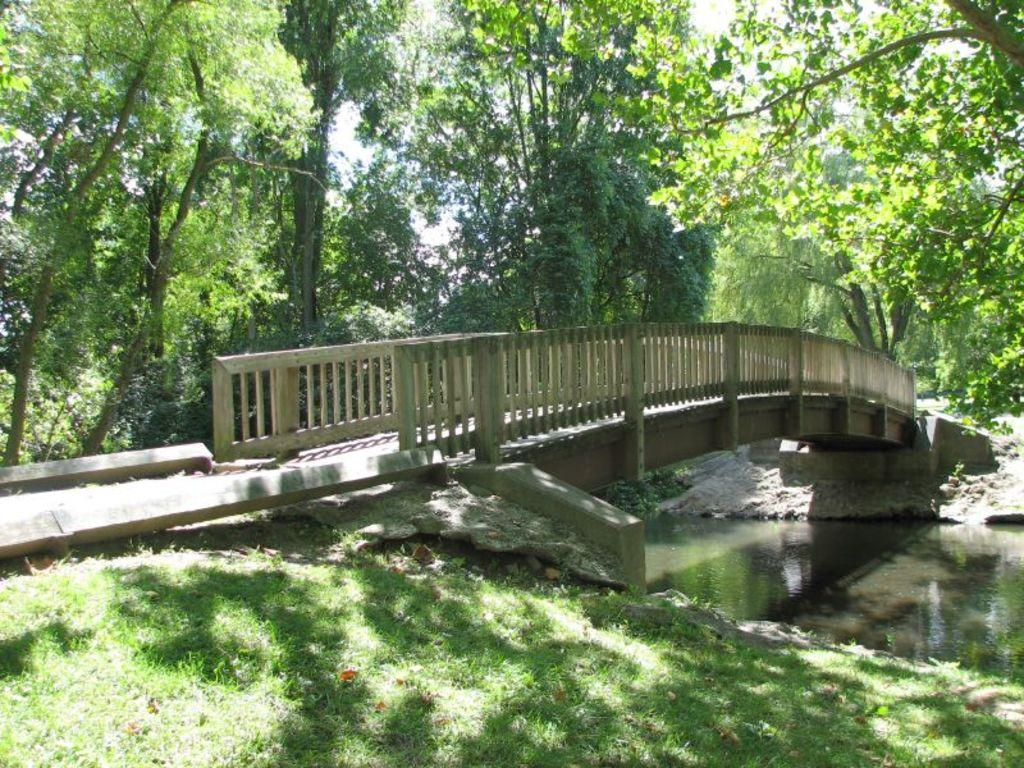What type of structure can be seen in the image? There is a bridge in the image. What type of vegetation is present in the image? There is grass in the image. What natural element is visible in the image? There is water in the image. What can be seen in the background of the image? There are trees visible in the background of the image. What type of selection process is being conducted in the image? There is no indication of a selection process in the image; it features a bridge, grass, water, and trees. Can you describe the ocean visible in the image? There is no ocean present in the image; it features a bridge, grass, water, and trees. 